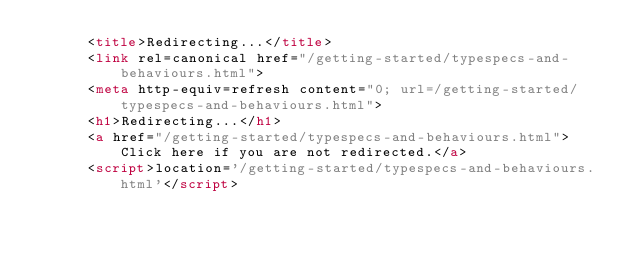<code> <loc_0><loc_0><loc_500><loc_500><_HTML_>      <title>Redirecting...</title>
      <link rel=canonical href="/getting-started/typespecs-and-behaviours.html">
      <meta http-equiv=refresh content="0; url=/getting-started/typespecs-and-behaviours.html">
      <h1>Redirecting...</h1>
      <a href="/getting-started/typespecs-and-behaviours.html">Click here if you are not redirected.</a>
      <script>location='/getting-started/typespecs-and-behaviours.html'</script>
</code> 